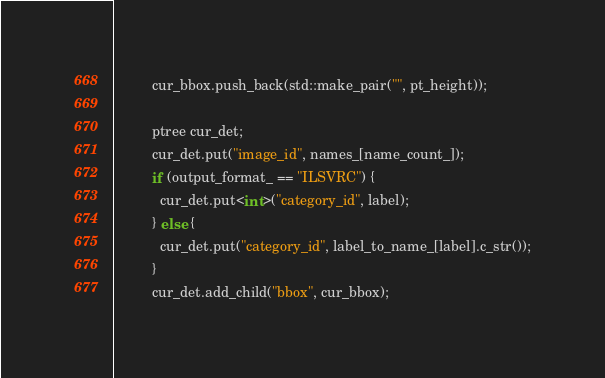Convert code to text. <code><loc_0><loc_0><loc_500><loc_500><_Cuda_>          cur_bbox.push_back(std::make_pair("", pt_height));

          ptree cur_det;
          cur_det.put("image_id", names_[name_count_]);
          if (output_format_ == "ILSVRC") {
            cur_det.put<int>("category_id", label);
          } else {
            cur_det.put("category_id", label_to_name_[label].c_str());
          }
          cur_det.add_child("bbox", cur_bbox);</code> 